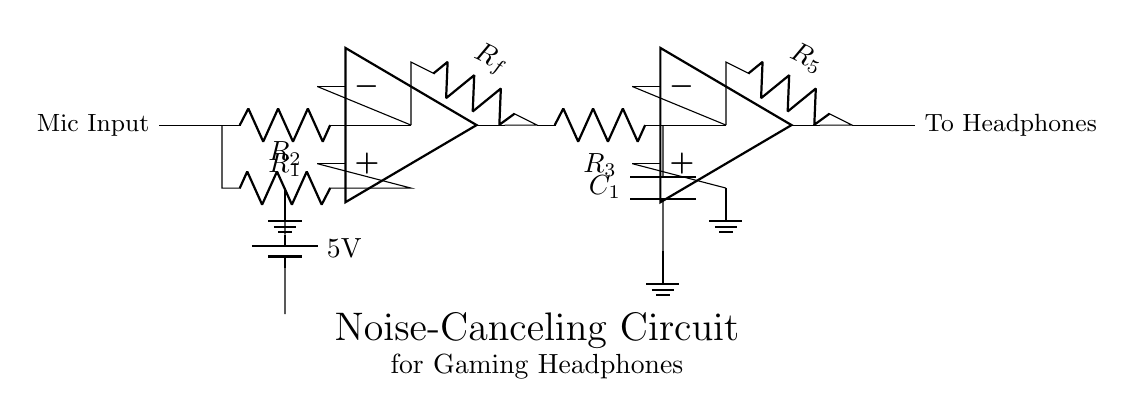What is the value of the input resistor? The input resistor is labeled as R1 in the circuit. It does not have a specific value written in the diagram.
Answer: R1 What type of components are R2 and Rf? R2 and Rf are both resistors, as indicated by the "R" labeling in the circuit.
Answer: Resistors How many operational amplifiers are present in this circuit? The circuit diagram shows two operational amplifiers represented by the op amp symbols.
Answer: 2 What is the purpose of the capacitor labeled C1? C1 is part of a low-pass filter in the circuit, which allows low-frequency signals to pass while attenuating higher frequencies.
Answer: Low-pass filter What is the power supply voltage in this circuit? The battery in the circuit is labeled with a potential difference of 5V, indicating it supplies that voltage to the circuit.
Answer: 5V Why is there a feedback loop involving Rf? The feedback loop with Rf is used to control the gain of the operational amplifier, helping to stabilize the circuit and improve noise-cancellation performance.
Answer: To control gain What is the function of the microphone input? The microphone input captures ambient noise and sends it to the circuit for cancellation, making it essential for the noise-canceling function of the headphones.
Answer: To capture noise 